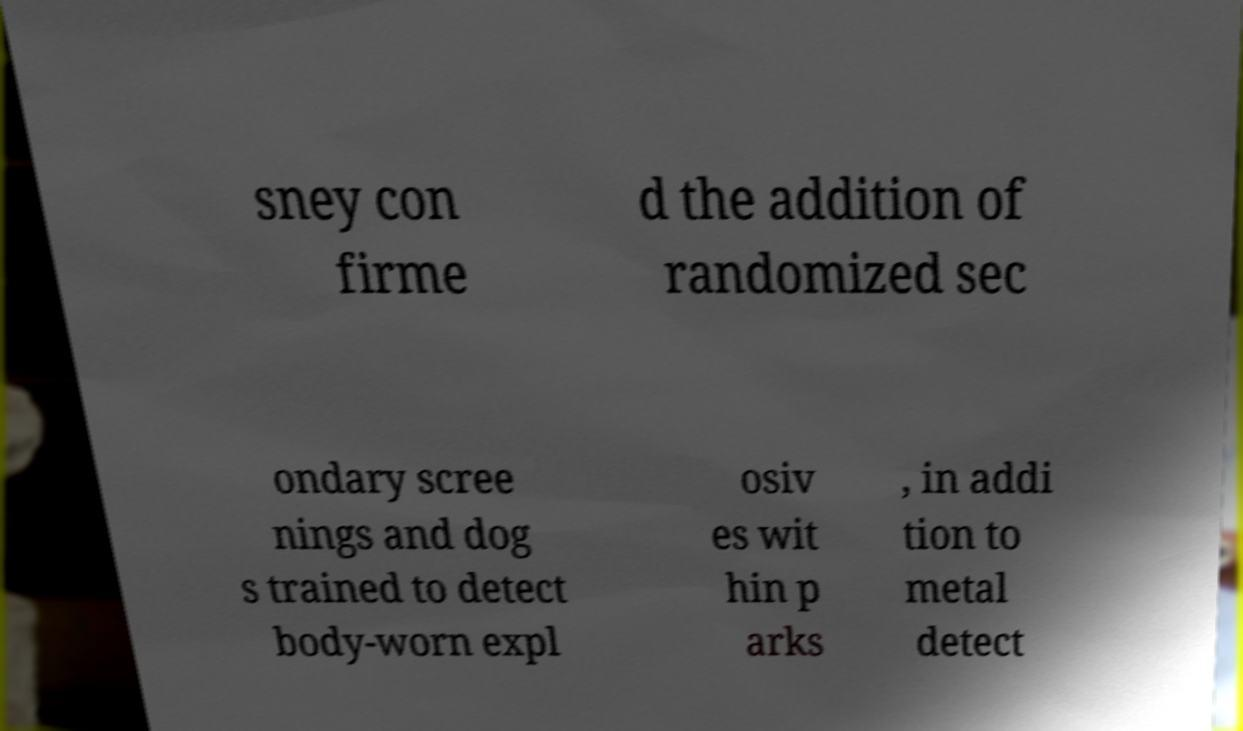I need the written content from this picture converted into text. Can you do that? sney con firme d the addition of randomized sec ondary scree nings and dog s trained to detect body-worn expl osiv es wit hin p arks , in addi tion to metal detect 